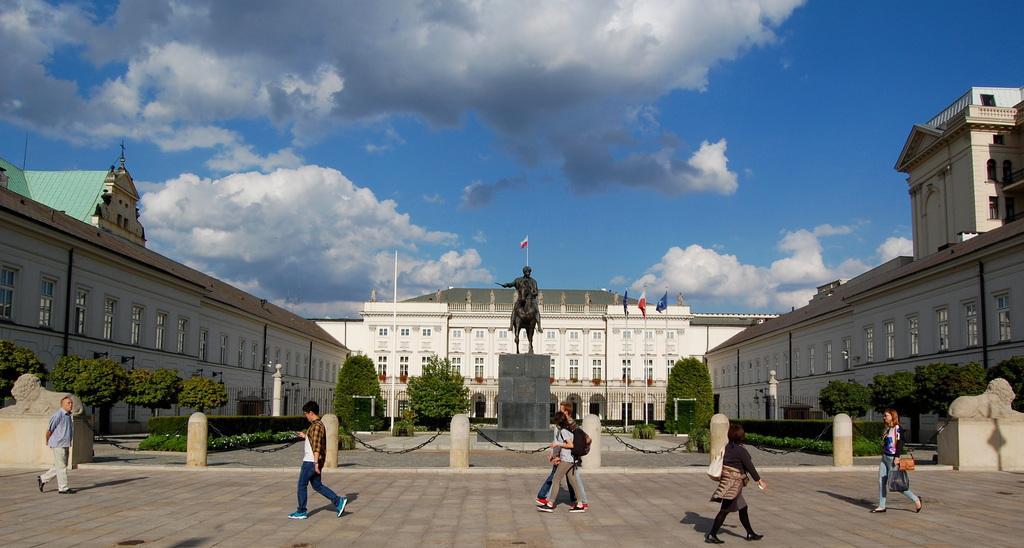Can you describe this image briefly? At the bottom of this image, there are persons in different color dresses, walking on the road. In the background, there are statues, trees, plants, buildings and there are clouds in the blue sky. 